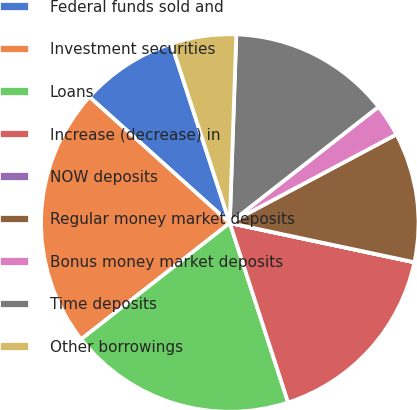<chart> <loc_0><loc_0><loc_500><loc_500><pie_chart><fcel>Federal funds sold and<fcel>Investment securities<fcel>Loans<fcel>Increase (decrease) in<fcel>NOW deposits<fcel>Regular money market deposits<fcel>Bonus money market deposits<fcel>Time deposits<fcel>Other borrowings<nl><fcel>8.34%<fcel>22.21%<fcel>19.44%<fcel>16.66%<fcel>0.01%<fcel>11.11%<fcel>2.78%<fcel>13.89%<fcel>5.56%<nl></chart> 